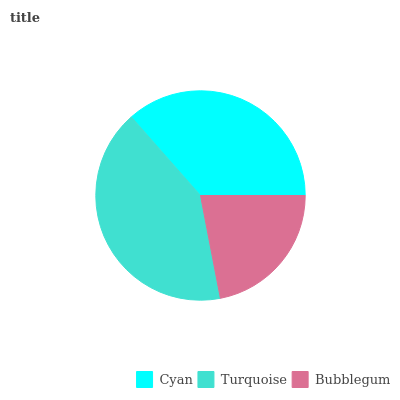Is Bubblegum the minimum?
Answer yes or no. Yes. Is Turquoise the maximum?
Answer yes or no. Yes. Is Turquoise the minimum?
Answer yes or no. No. Is Bubblegum the maximum?
Answer yes or no. No. Is Turquoise greater than Bubblegum?
Answer yes or no. Yes. Is Bubblegum less than Turquoise?
Answer yes or no. Yes. Is Bubblegum greater than Turquoise?
Answer yes or no. No. Is Turquoise less than Bubblegum?
Answer yes or no. No. Is Cyan the high median?
Answer yes or no. Yes. Is Cyan the low median?
Answer yes or no. Yes. Is Turquoise the high median?
Answer yes or no. No. Is Turquoise the low median?
Answer yes or no. No. 